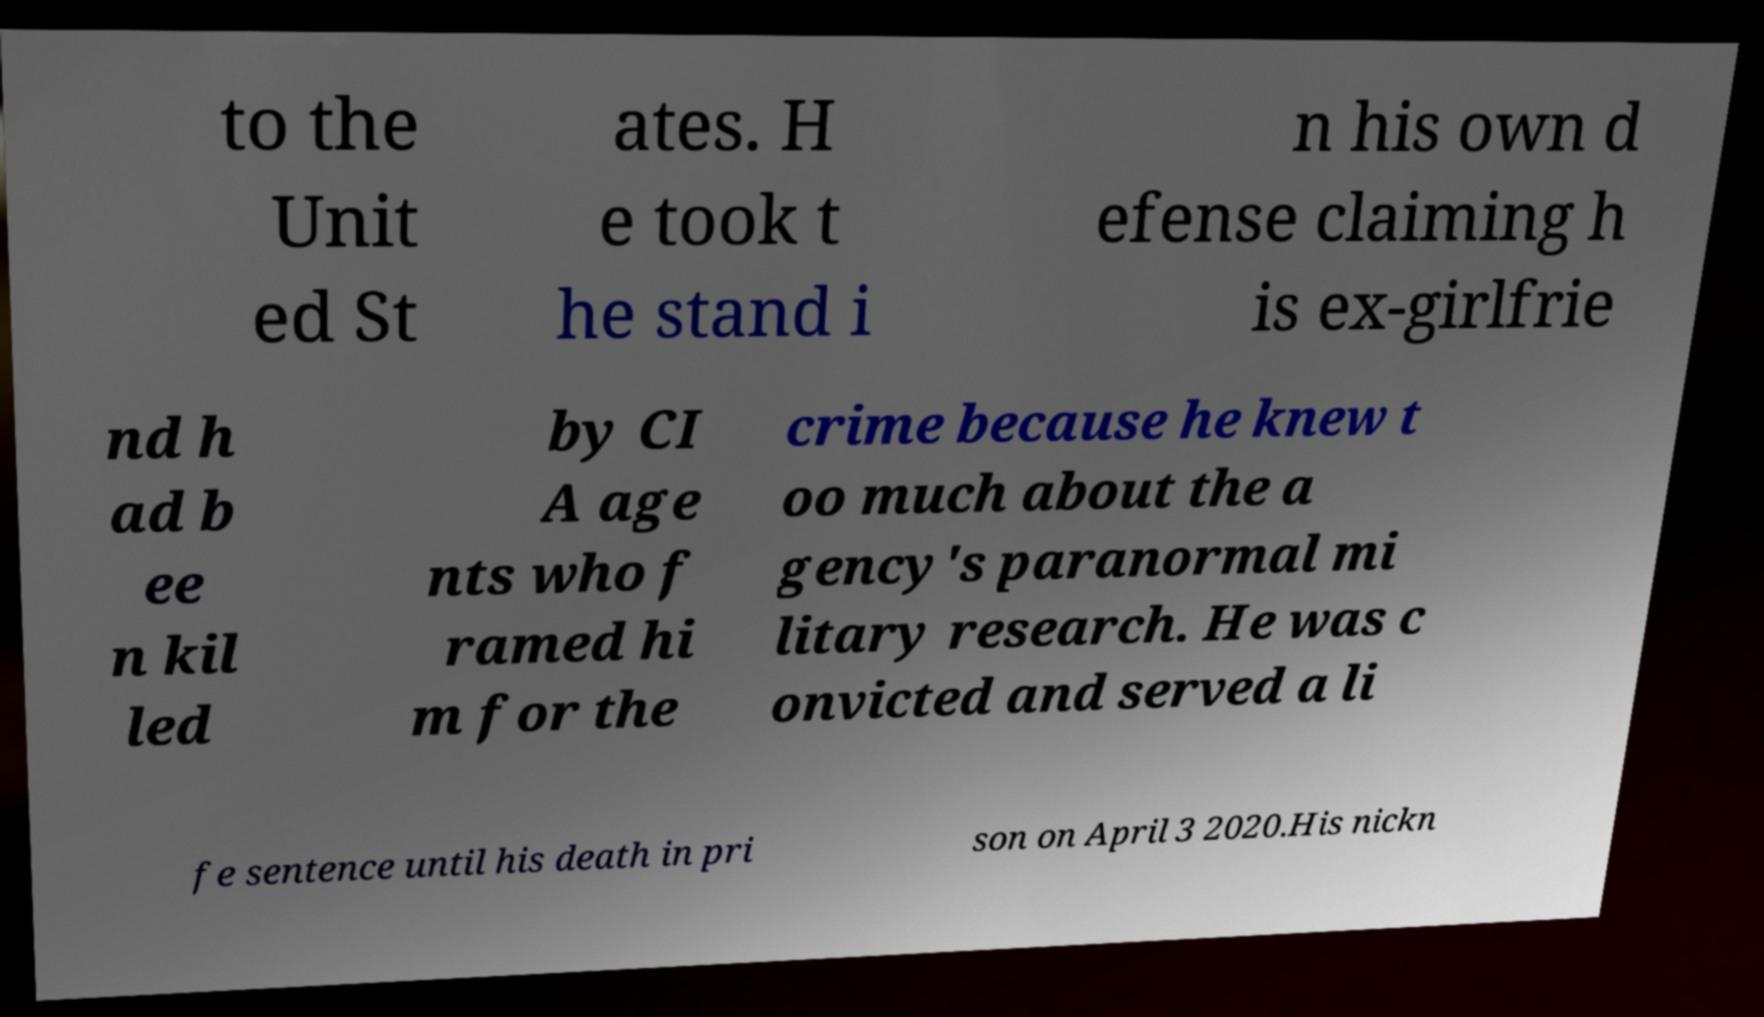Could you assist in decoding the text presented in this image and type it out clearly? to the Unit ed St ates. H e took t he stand i n his own d efense claiming h is ex-girlfrie nd h ad b ee n kil led by CI A age nts who f ramed hi m for the crime because he knew t oo much about the a gency's paranormal mi litary research. He was c onvicted and served a li fe sentence until his death in pri son on April 3 2020.His nickn 